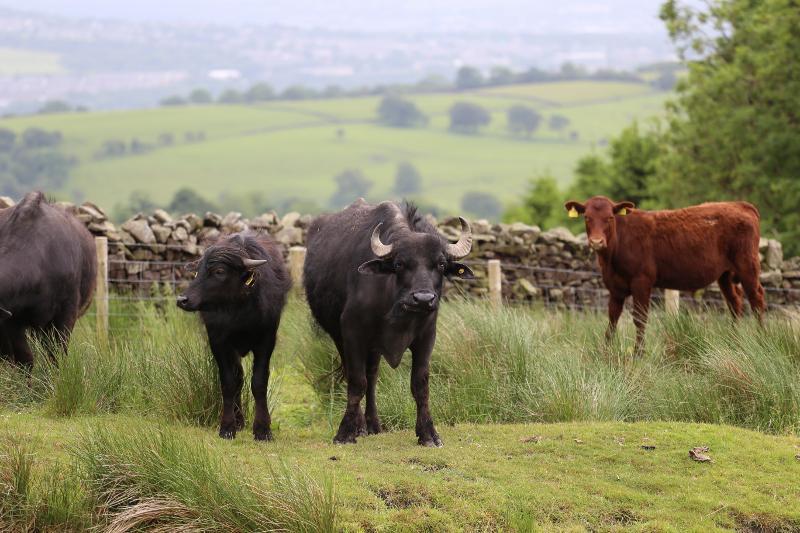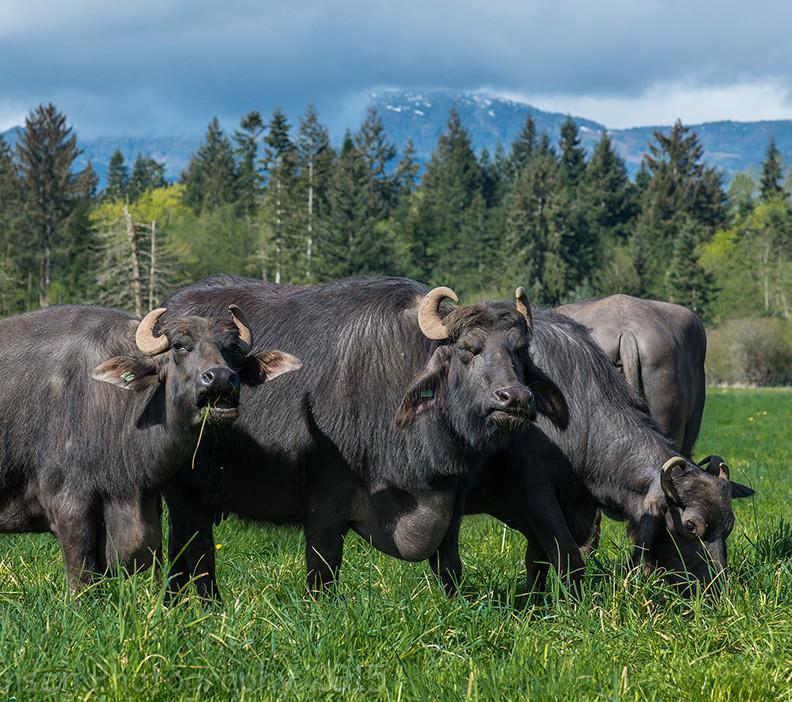The first image is the image on the left, the second image is the image on the right. Assess this claim about the two images: "In one image there are at least three standing water buffaloes where one is facing a different direction than the others.". Correct or not? Answer yes or no. Yes. The first image is the image on the left, the second image is the image on the right. Assess this claim about the two images: "The left image contains only very dark hooved animals surrounded by bright green grass, with the foreground animals facing directly forward.". Correct or not? Answer yes or no. No. 